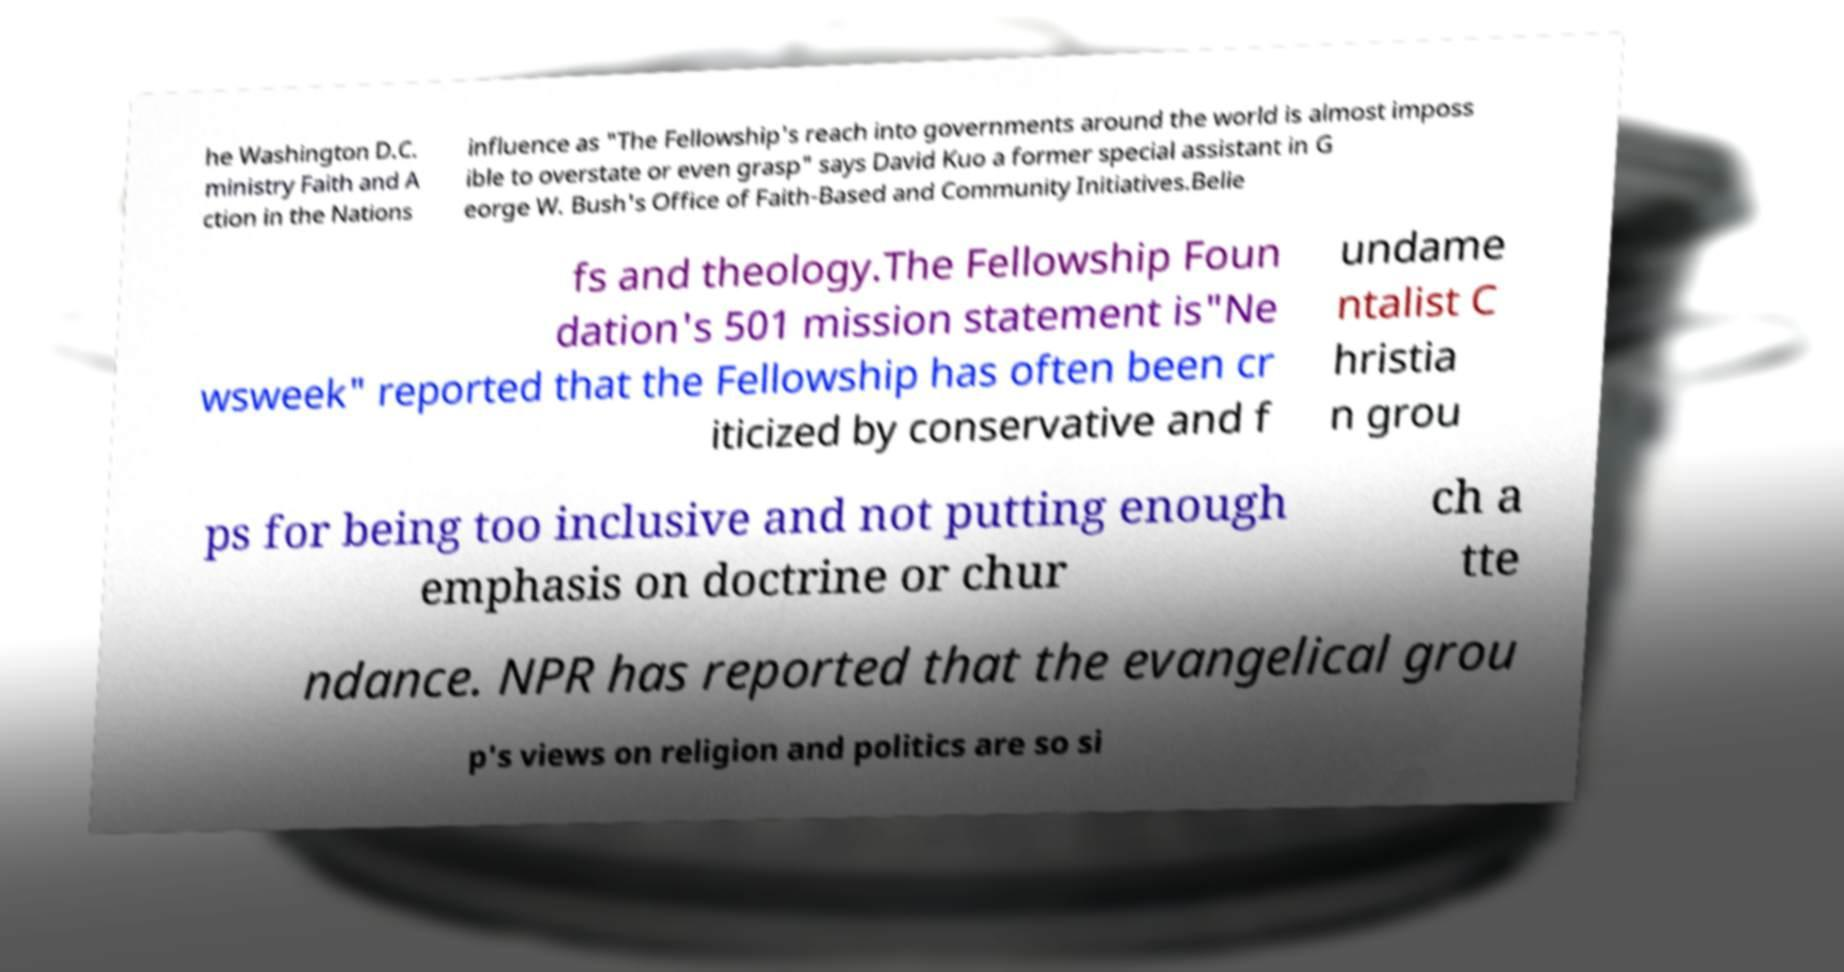Please read and relay the text visible in this image. What does it say? he Washington D.C. ministry Faith and A ction in the Nations influence as "The Fellowship's reach into governments around the world is almost imposs ible to overstate or even grasp" says David Kuo a former special assistant in G eorge W. Bush's Office of Faith-Based and Community Initiatives.Belie fs and theology.The Fellowship Foun dation's 501 mission statement is"Ne wsweek" reported that the Fellowship has often been cr iticized by conservative and f undame ntalist C hristia n grou ps for being too inclusive and not putting enough emphasis on doctrine or chur ch a tte ndance. NPR has reported that the evangelical grou p's views on religion and politics are so si 